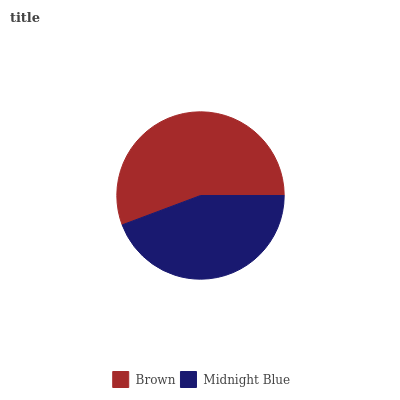Is Midnight Blue the minimum?
Answer yes or no. Yes. Is Brown the maximum?
Answer yes or no. Yes. Is Midnight Blue the maximum?
Answer yes or no. No. Is Brown greater than Midnight Blue?
Answer yes or no. Yes. Is Midnight Blue less than Brown?
Answer yes or no. Yes. Is Midnight Blue greater than Brown?
Answer yes or no. No. Is Brown less than Midnight Blue?
Answer yes or no. No. Is Brown the high median?
Answer yes or no. Yes. Is Midnight Blue the low median?
Answer yes or no. Yes. Is Midnight Blue the high median?
Answer yes or no. No. Is Brown the low median?
Answer yes or no. No. 